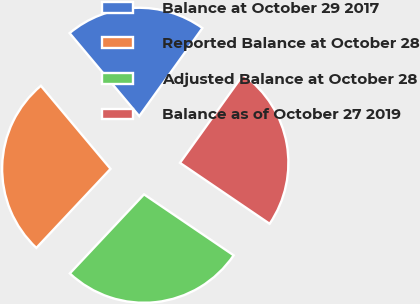<chart> <loc_0><loc_0><loc_500><loc_500><pie_chart><fcel>Balance at October 29 2017<fcel>Reported Balance at October 28<fcel>Adjusted Balance at October 28<fcel>Balance as of October 27 2019<nl><fcel>21.01%<fcel>26.9%<fcel>27.49%<fcel>24.6%<nl></chart> 